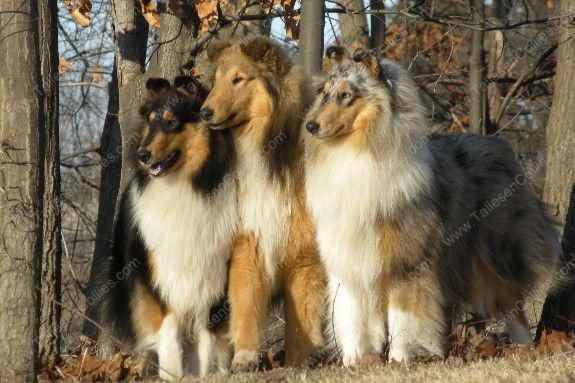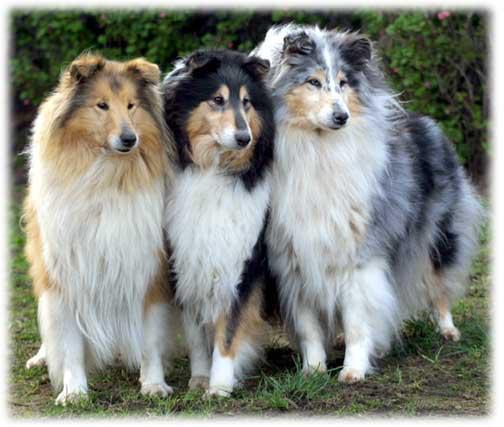The first image is the image on the left, the second image is the image on the right. For the images shown, is this caption "Three collies pose together in both of the pictures." true? Answer yes or no. Yes. The first image is the image on the left, the second image is the image on the right. Evaluate the accuracy of this statement regarding the images: "Each image contains exactly three dogs.". Is it true? Answer yes or no. Yes. 